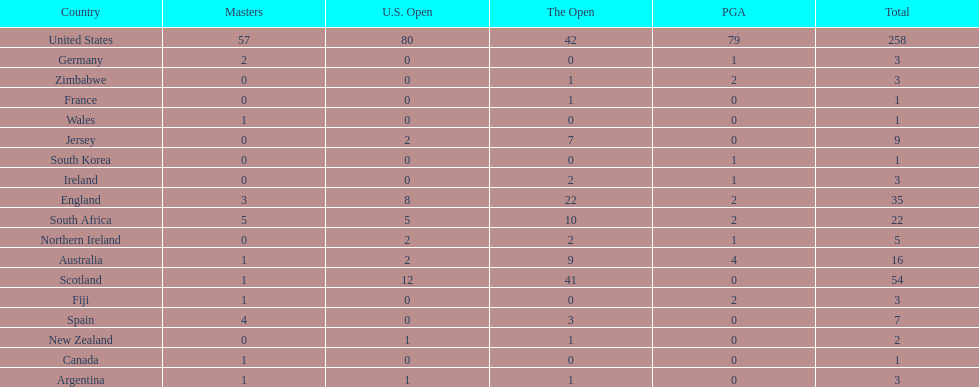How many total championships does spain have? 7. 